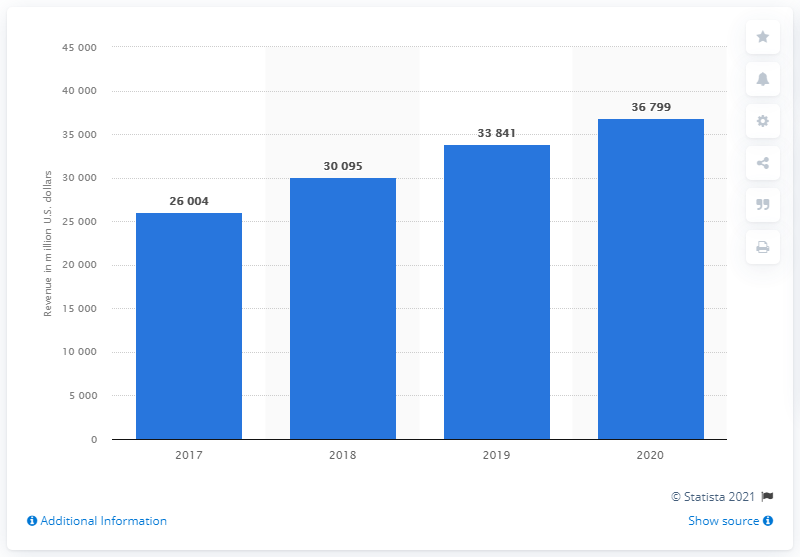Identify some key points in this picture. Northrop Grumman generated approximately $36.799 billion in revenue during the 2020 fiscal year. 